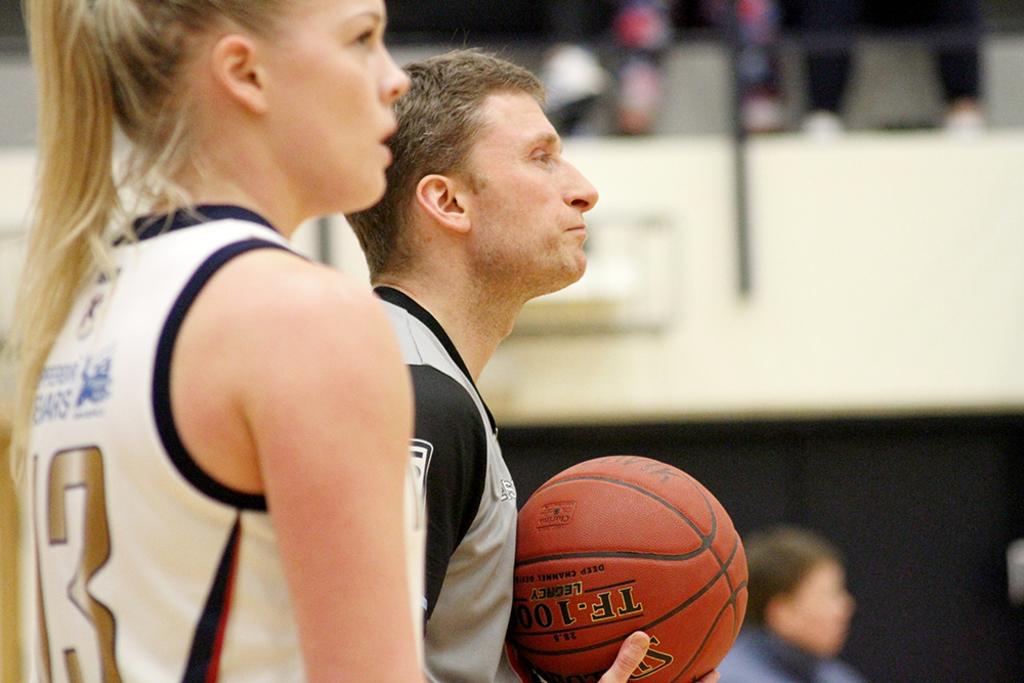What player number is the player on the left?
Your answer should be very brief. 13. What are the words on the basketball?
Your answer should be compact. Tf. 